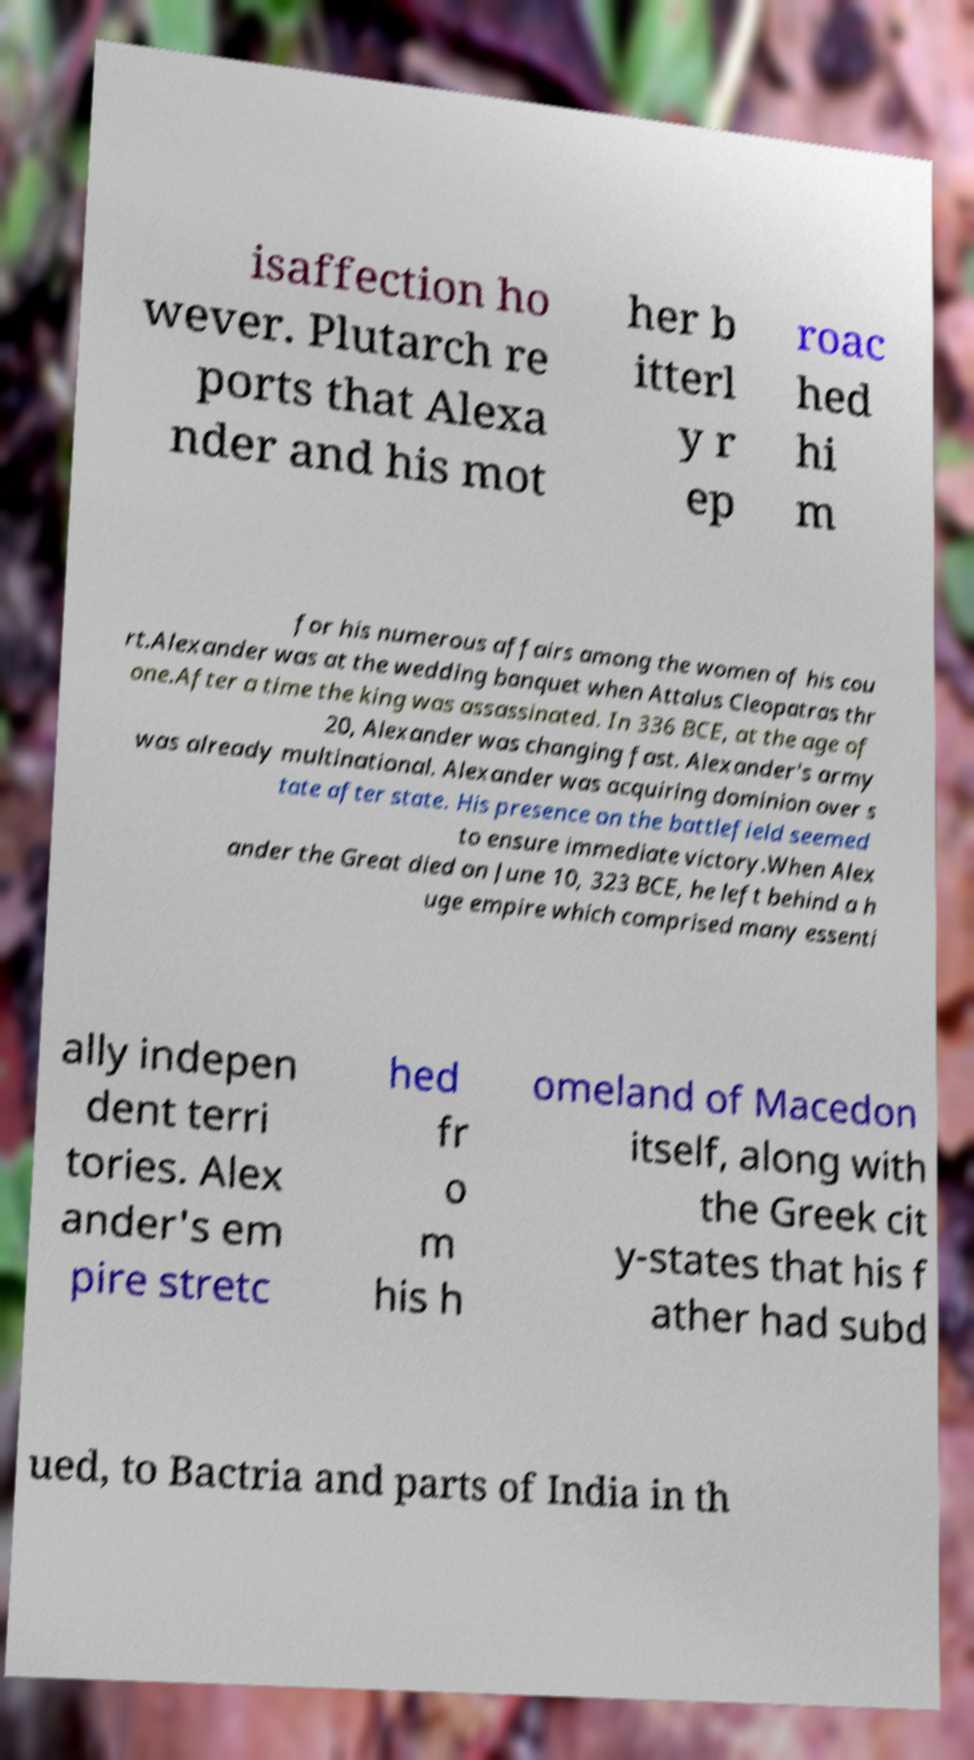Could you assist in decoding the text presented in this image and type it out clearly? isaffection ho wever. Plutarch re ports that Alexa nder and his mot her b itterl y r ep roac hed hi m for his numerous affairs among the women of his cou rt.Alexander was at the wedding banquet when Attalus Cleopatras thr one.After a time the king was assassinated. In 336 BCE, at the age of 20, Alexander was changing fast. Alexander's army was already multinational. Alexander was acquiring dominion over s tate after state. His presence on the battlefield seemed to ensure immediate victory.When Alex ander the Great died on June 10, 323 BCE, he left behind a h uge empire which comprised many essenti ally indepen dent terri tories. Alex ander's em pire stretc hed fr o m his h omeland of Macedon itself, along with the Greek cit y-states that his f ather had subd ued, to Bactria and parts of India in th 